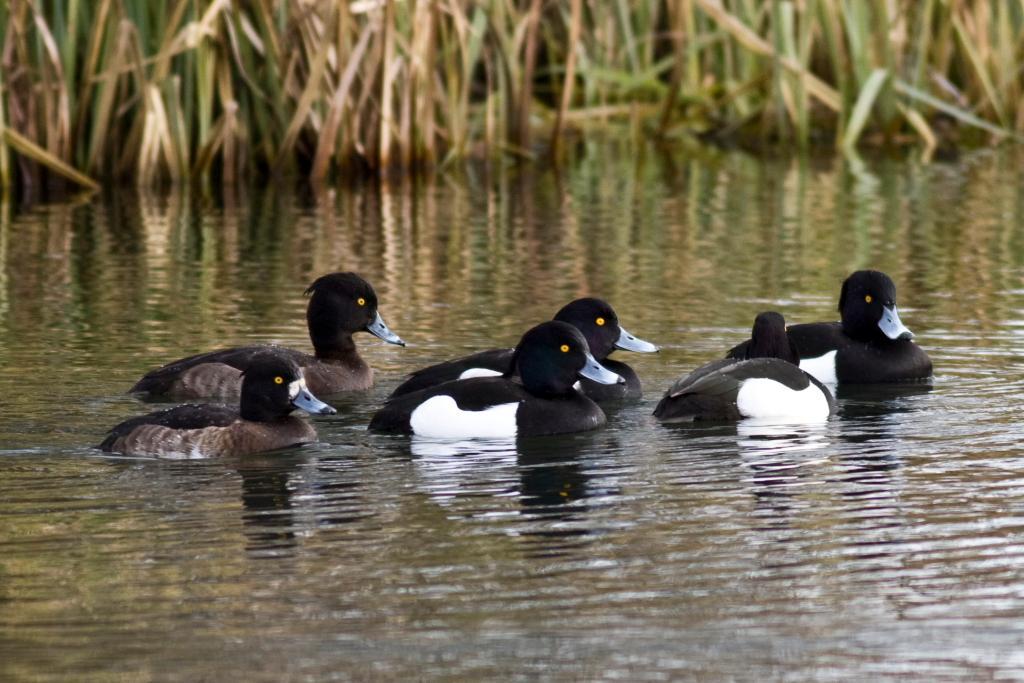How would you summarize this image in a sentence or two? In this picture there are ducks on the water. At the back there are plants. At the bottom there is water and there are reflections of plants and ducks on the water. 